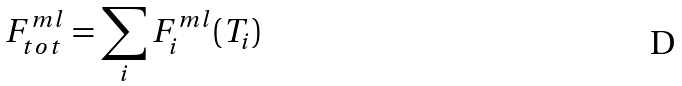<formula> <loc_0><loc_0><loc_500><loc_500>F ^ { m l } _ { t o t } = \sum _ { i } F ^ { m l } _ { i } ( T _ { i } )</formula> 